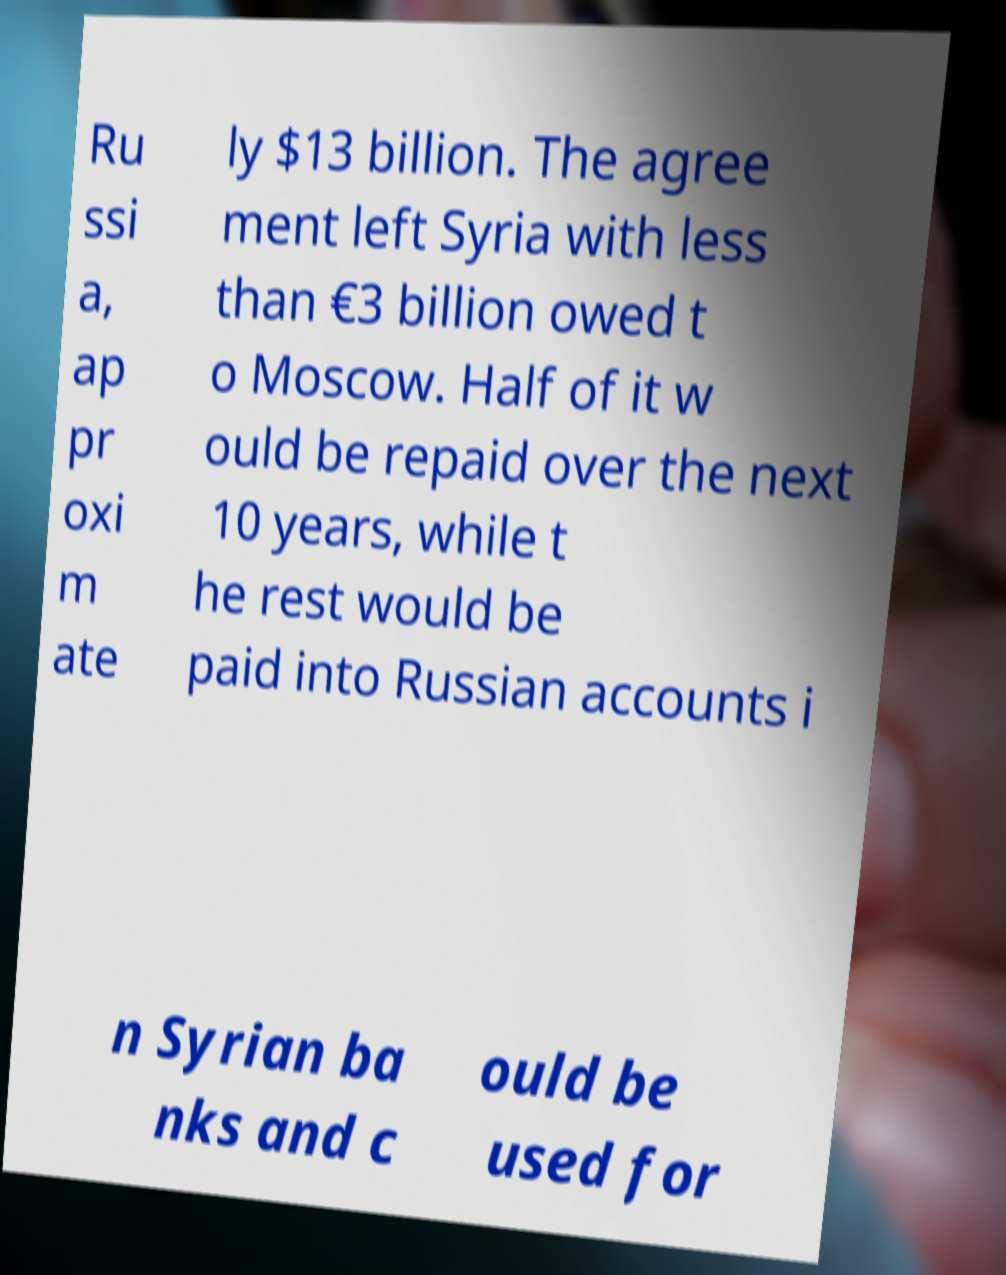Please identify and transcribe the text found in this image. Ru ssi a, ap pr oxi m ate ly $13 billion. The agree ment left Syria with less than €3 billion owed t o Moscow. Half of it w ould be repaid over the next 10 years, while t he rest would be paid into Russian accounts i n Syrian ba nks and c ould be used for 